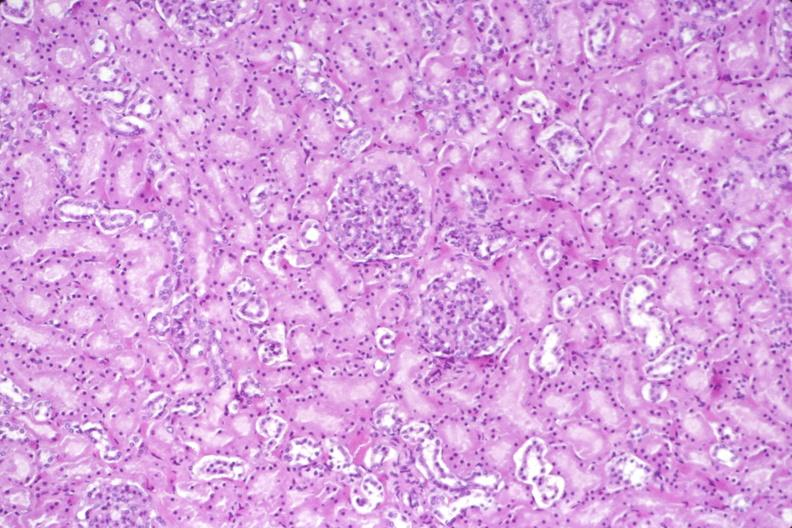where is this?
Answer the question using a single word or phrase. Urinary 